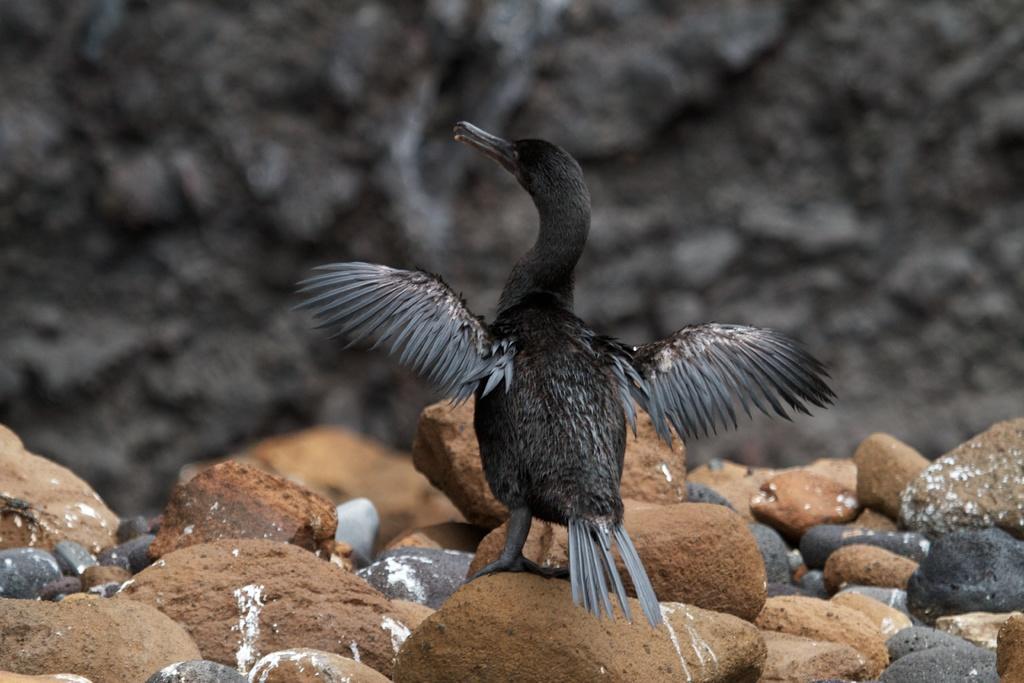How would you summarize this image in a sentence or two? In the image we can see a bird, black and gray in color. There are many stones of different sizes and colors, and the background is dark. 